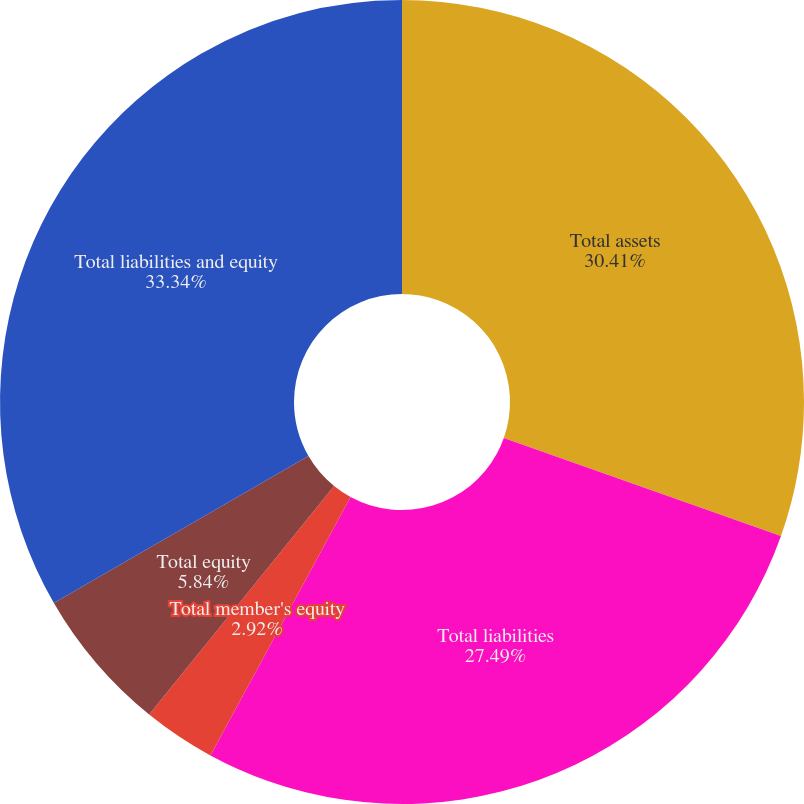<chart> <loc_0><loc_0><loc_500><loc_500><pie_chart><fcel>Total assets<fcel>Total liabilities<fcel>Total member's equity<fcel>Noncontrolling interests<fcel>Total equity<fcel>Total liabilities and equity<nl><fcel>30.41%<fcel>27.49%<fcel>2.92%<fcel>0.0%<fcel>5.84%<fcel>33.33%<nl></chart> 